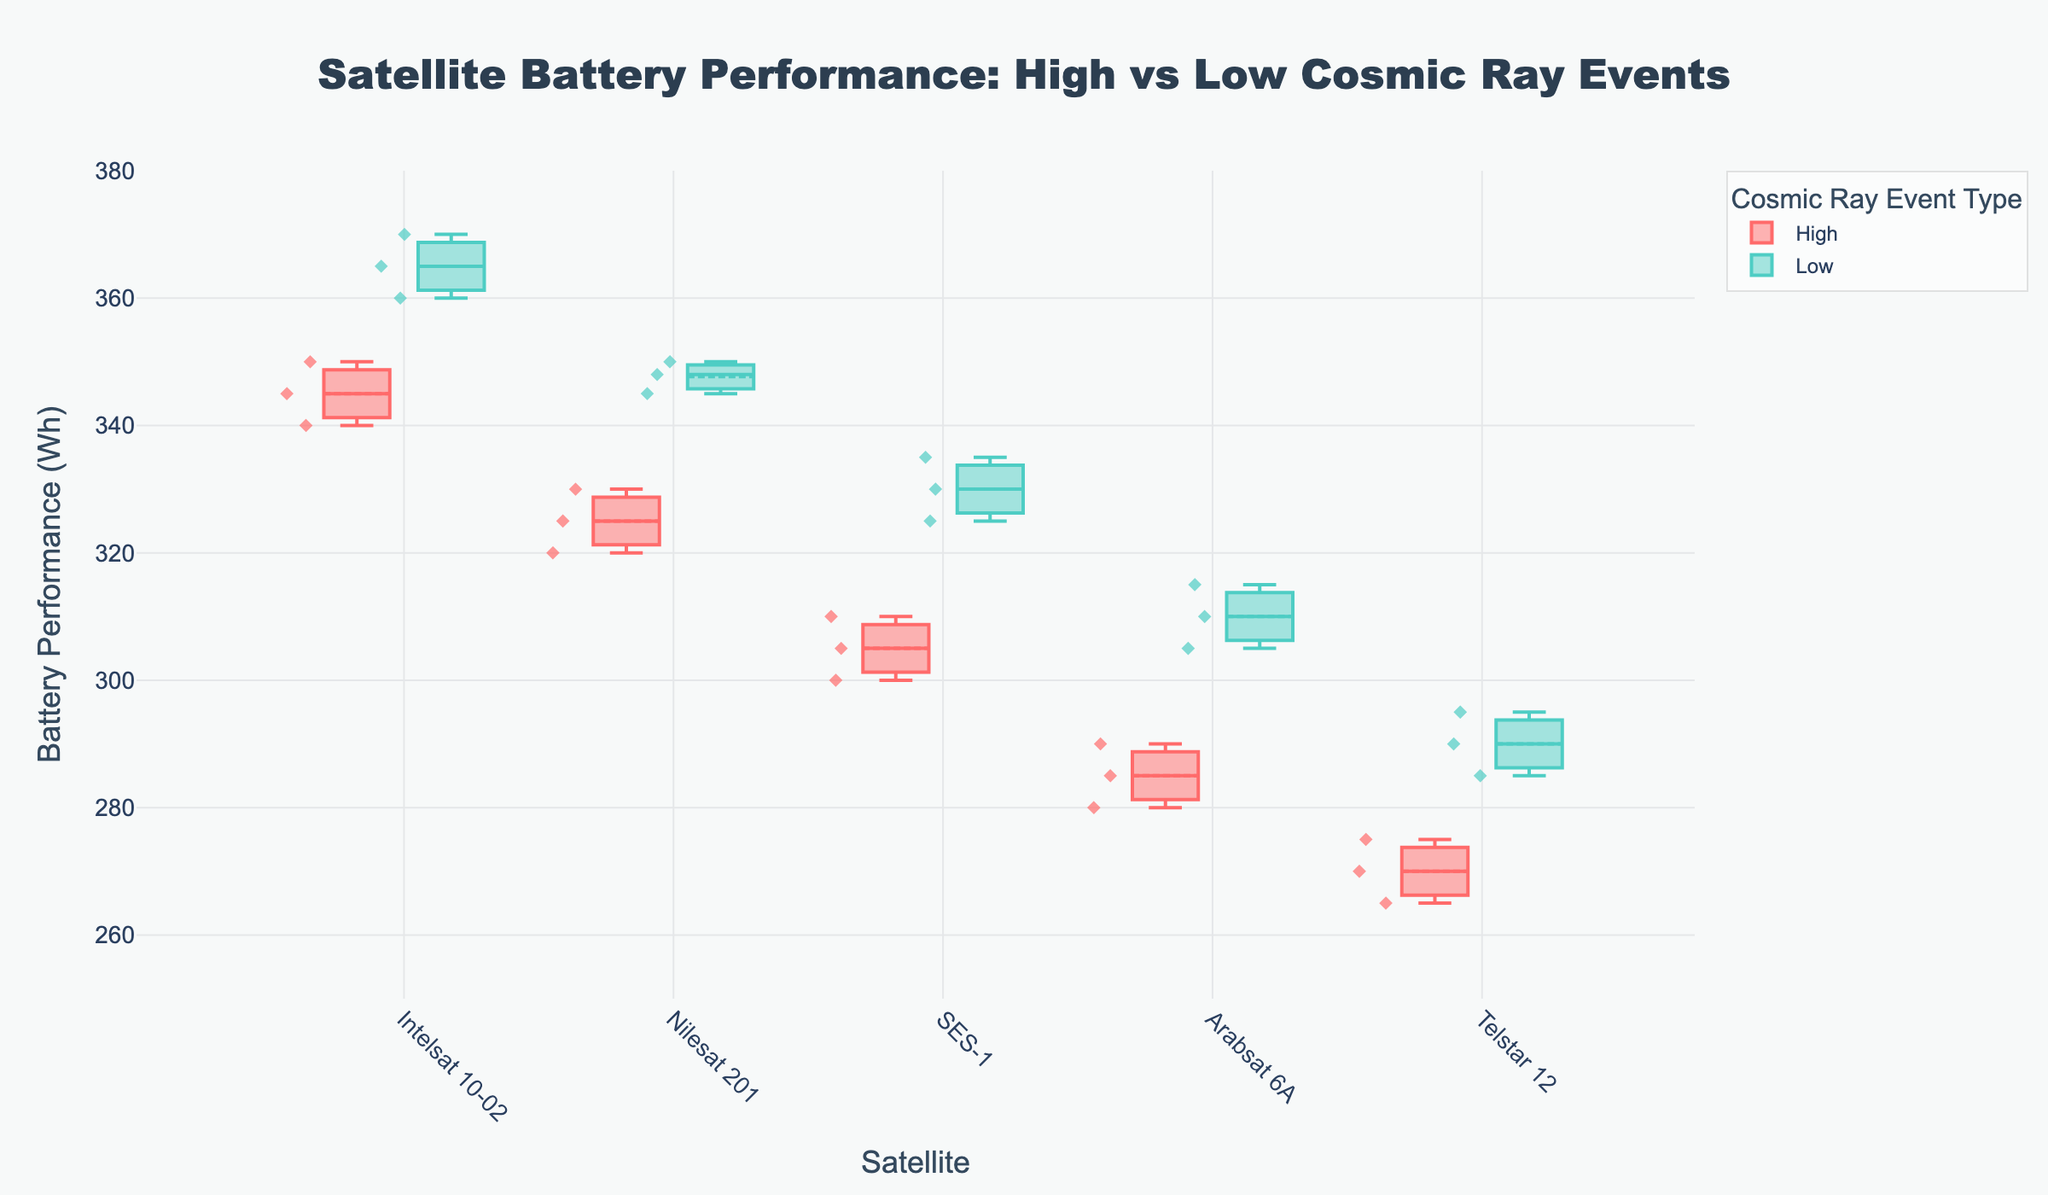What is the title of the plot? The plot's title is displayed at the top of the figure. It provides a summary of what the figure represents.
Answer: Satellite Battery Performance: High vs Low Cosmic Ray Events Which satellite has the highest median battery performance during low cosmic ray events? To find the median value for a satellite during low cosmic ray events, look at the middle line inside the box for each satellite under the "Low" category.
Answer: Intelsat 10-02 Does the battery performance vary more during high or low cosmic ray events for SES-1? Variation is typically depicted by the size of the box in a box plot, which represents the interquartile range. Compare the size of the boxes for SES-1 under "High" vs "Low" events.
Answer: High What is the interquartile range (IQR) of battery performance for Nilesat 201 during high cosmic ray events? The IQR is the range between the third quartile (top of the box) and the first quartile (bottom of the box). Find these values for Nilesat 201 under "High" events and subtract the lower from the upper.
Answer: 10 Wh (approx) Which event type shows lower overall battery performance for Arabsat 6A? Compare the median lines (middle lines) of the box plots for Arabsat 6A under both "High" and "Low" categories.
Answer: High Are there any outliers in the battery performance data for Telstar 12 during low cosmic ray events? Outliers are usually indicated by individual points outside the whiskers of the box plot. Check for any points detached from the whiskers for Telstar 12 under "Low" events.
Answer: No Compare the average battery performance between high and low cosmic ray events for Intelsat 10-02. Identify the mean values (as indicated by the small square or dot within the box) for both high and low events for Intelsat 10-02 and compare them.
Answer: Higher during low events Which satellite shows the least difference in median battery performance between high and low cosmic ray events? Look at the median lines (middle lines in the boxes) for each satellite under both categories and compare the differences.
Answer: SES-1 